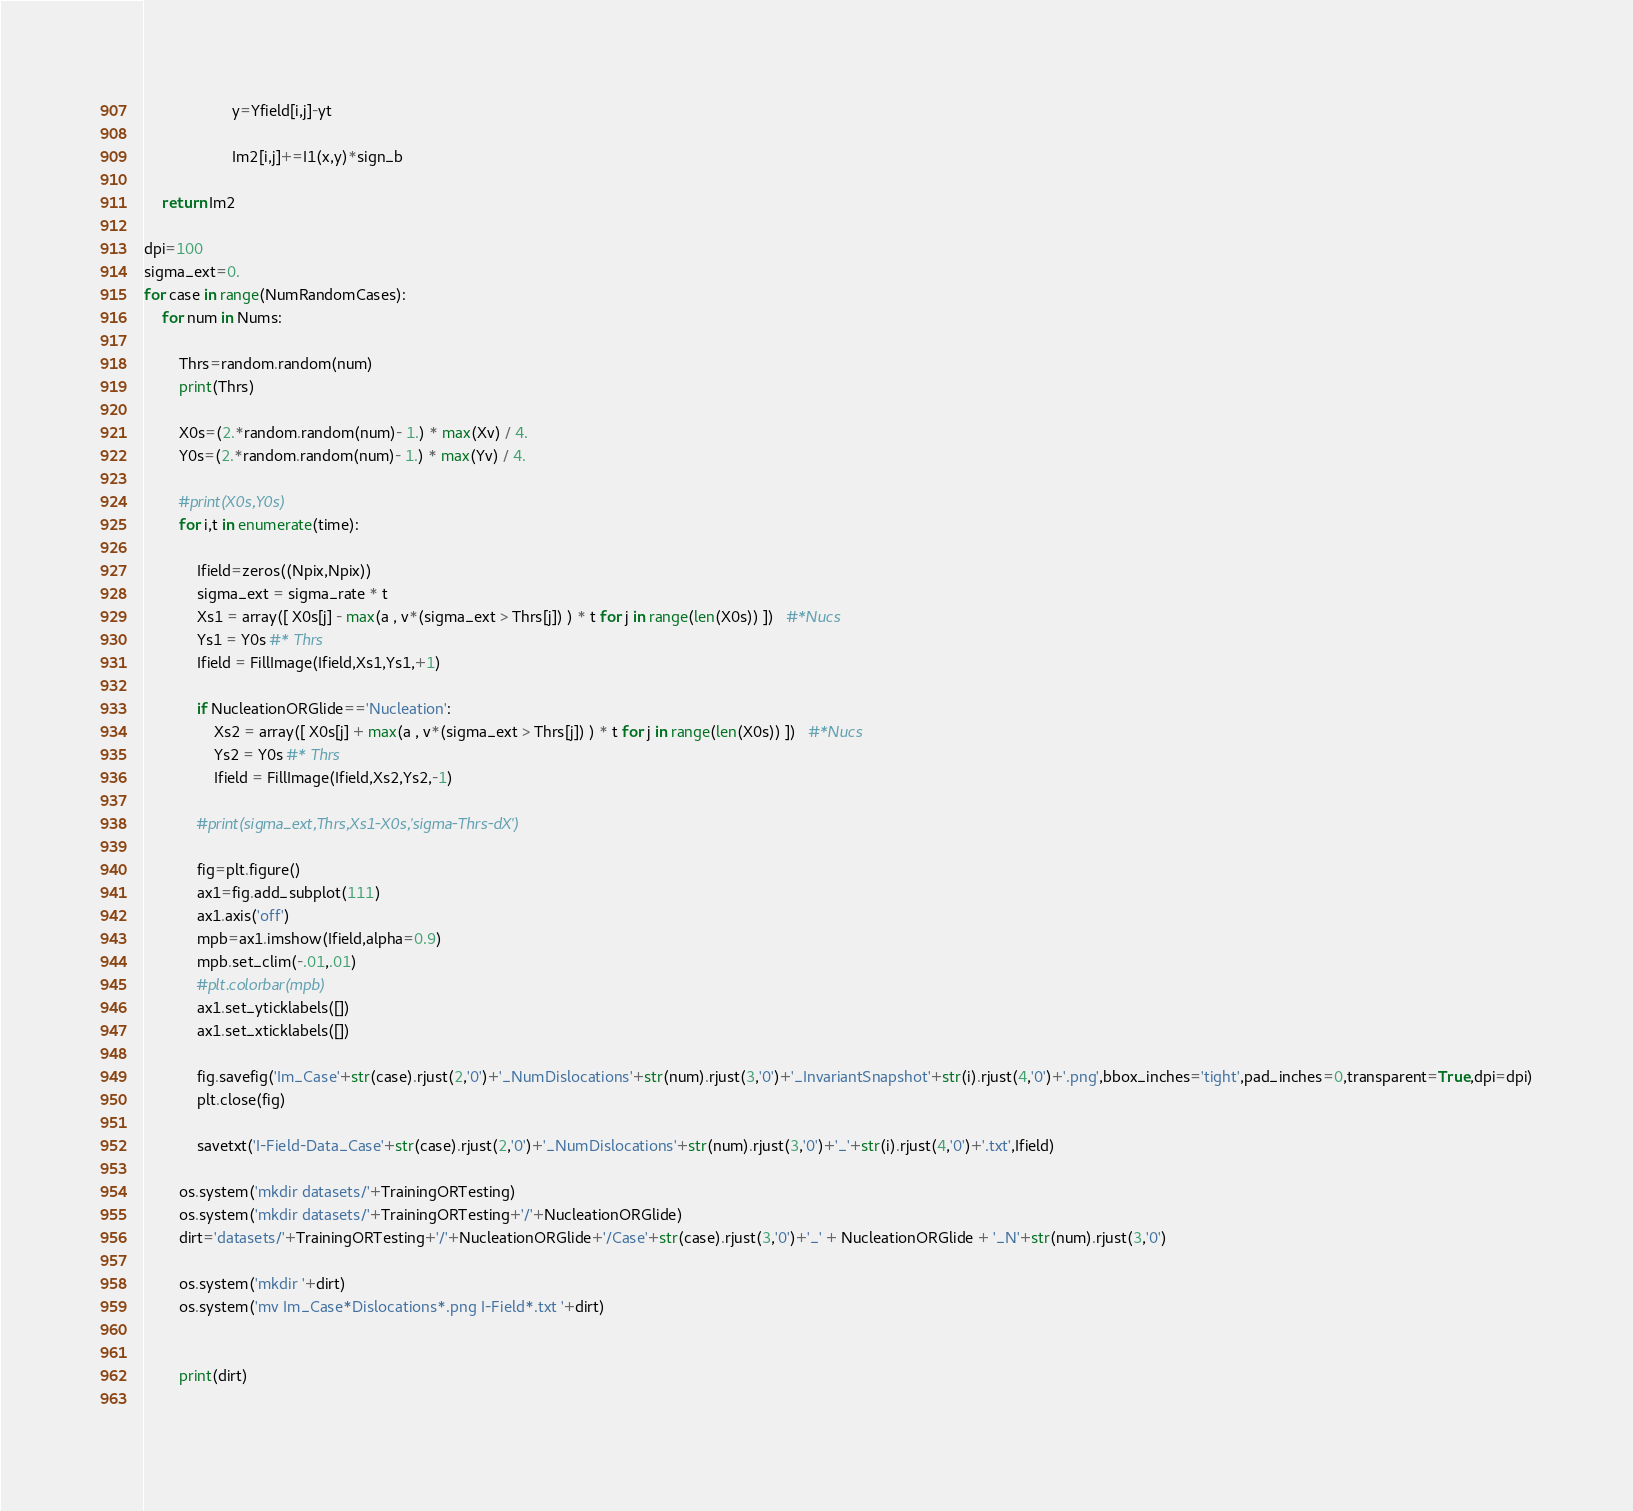<code> <loc_0><loc_0><loc_500><loc_500><_Python_>                    y=Yfield[i,j]-yt          

                    Im2[i,j]+=I1(x,y)*sign_b
    
    return Im2

dpi=100
sigma_ext=0.
for case in range(NumRandomCases):
    for num in Nums:

        Thrs=random.random(num)
        print(Thrs)

        X0s=(2.*random.random(num)- 1.) * max(Xv) / 4.
        Y0s=(2.*random.random(num)- 1.) * max(Yv) / 4.

        #print(X0s,Y0s)
        for i,t in enumerate(time):  
              
            Ifield=zeros((Npix,Npix))
            sigma_ext = sigma_rate * t
            Xs1 = array([ X0s[j] - max(a , v*(sigma_ext > Thrs[j]) ) * t for j in range(len(X0s)) ])   #*Nucs
            Ys1 = Y0s #* Thrs
            Ifield = FillImage(Ifield,Xs1,Ys1,+1)

            if NucleationORGlide=='Nucleation':
                Xs2 = array([ X0s[j] + max(a , v*(sigma_ext > Thrs[j]) ) * t for j in range(len(X0s)) ])   #*Nucs
                Ys2 = Y0s #* Thrs
                Ifield = FillImage(Ifield,Xs2,Ys2,-1)
            
            #print(sigma_ext,Thrs,Xs1-X0s,'sigma-Thrs-dX')

            fig=plt.figure()
            ax1=fig.add_subplot(111)
            ax1.axis('off')
            mpb=ax1.imshow(Ifield,alpha=0.9)            
            mpb.set_clim(-.01,.01)            
            #plt.colorbar(mpb)
            ax1.set_yticklabels([])
            ax1.set_xticklabels([])

            fig.savefig('Im_Case'+str(case).rjust(2,'0')+'_NumDislocations'+str(num).rjust(3,'0')+'_InvariantSnapshot'+str(i).rjust(4,'0')+'.png',bbox_inches='tight',pad_inches=0,transparent=True,dpi=dpi)
            plt.close(fig)

            savetxt('I-Field-Data_Case'+str(case).rjust(2,'0')+'_NumDislocations'+str(num).rjust(3,'0')+'_'+str(i).rjust(4,'0')+'.txt',Ifield)

        os.system('mkdir datasets/'+TrainingORTesting)
        os.system('mkdir datasets/'+TrainingORTesting+'/'+NucleationORGlide)
        dirt='datasets/'+TrainingORTesting+'/'+NucleationORGlide+'/Case'+str(case).rjust(3,'0')+'_' + NucleationORGlide + '_N'+str(num).rjust(3,'0')

        os.system('mkdir '+dirt)
        os.system('mv Im_Case*Dislocations*.png I-Field*.txt '+dirt)
        
        
        print(dirt)
        

</code> 